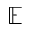<formula> <loc_0><loc_0><loc_500><loc_500>\mathbb { E }</formula> 